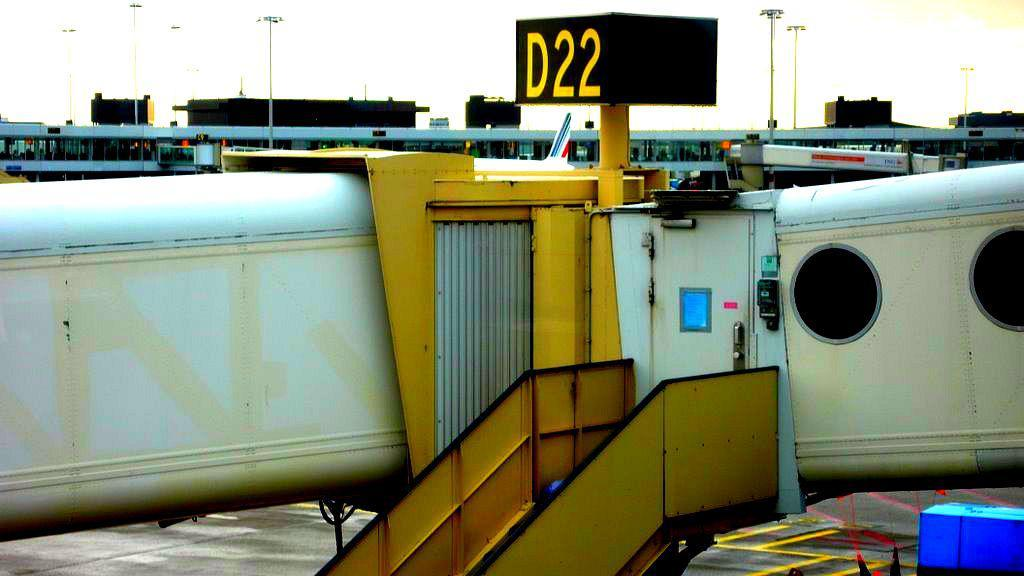<image>
Provide a brief description of the given image. An aircraft boarding ramp is connected to terminal D22. 